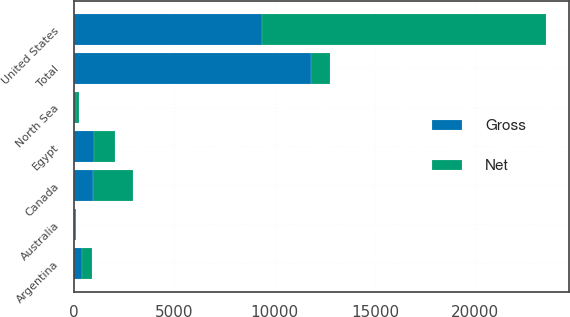<chart> <loc_0><loc_0><loc_500><loc_500><stacked_bar_chart><ecel><fcel>United States<fcel>Canada<fcel>Egypt<fcel>Australia<fcel>North Sea<fcel>Argentina<fcel>Total<nl><fcel>Net<fcel>14164<fcel>2000<fcel>1040<fcel>49<fcel>161<fcel>475<fcel>939<nl><fcel>Gross<fcel>9346<fcel>939<fcel>992<fcel>23<fcel>104<fcel>396<fcel>11800<nl></chart> 